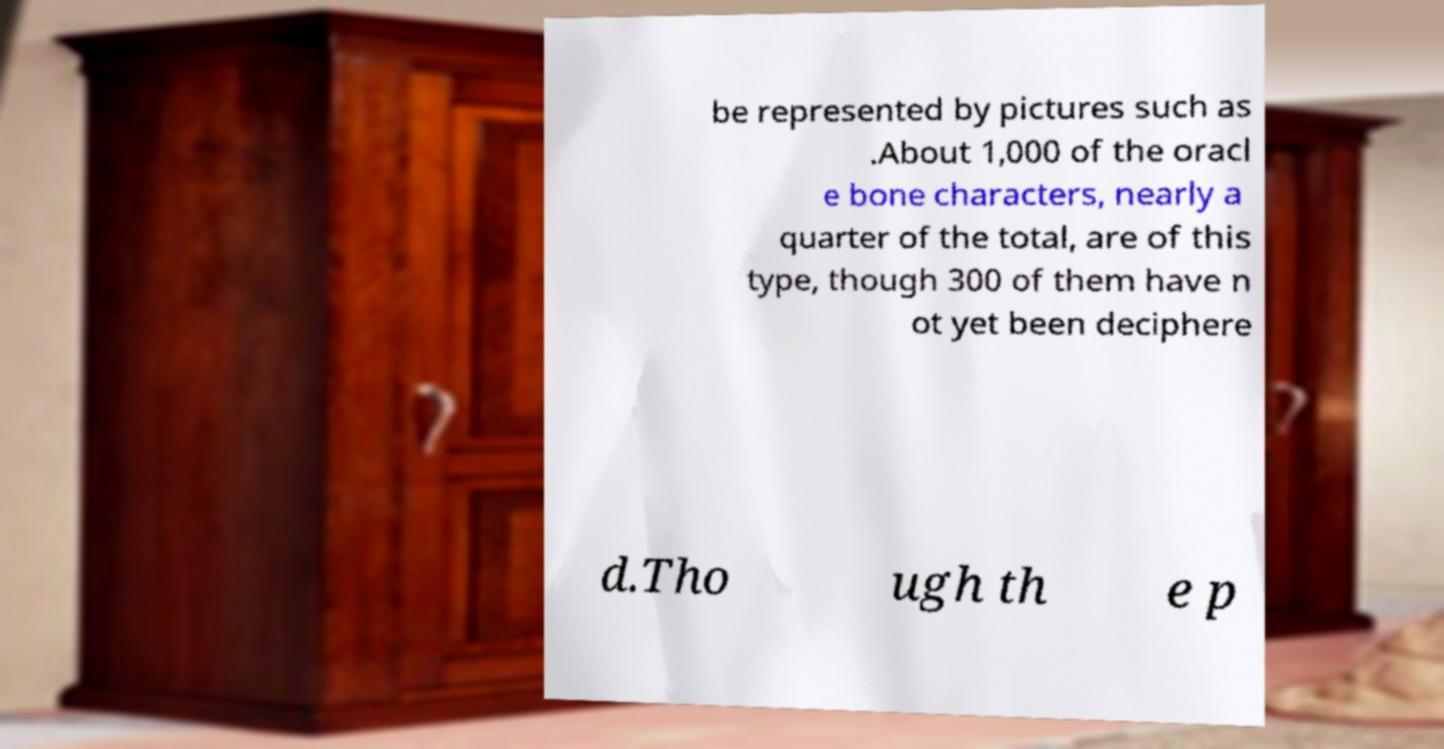Please identify and transcribe the text found in this image. be represented by pictures such as .About 1,000 of the oracl e bone characters, nearly a quarter of the total, are of this type, though 300 of them have n ot yet been deciphere d.Tho ugh th e p 